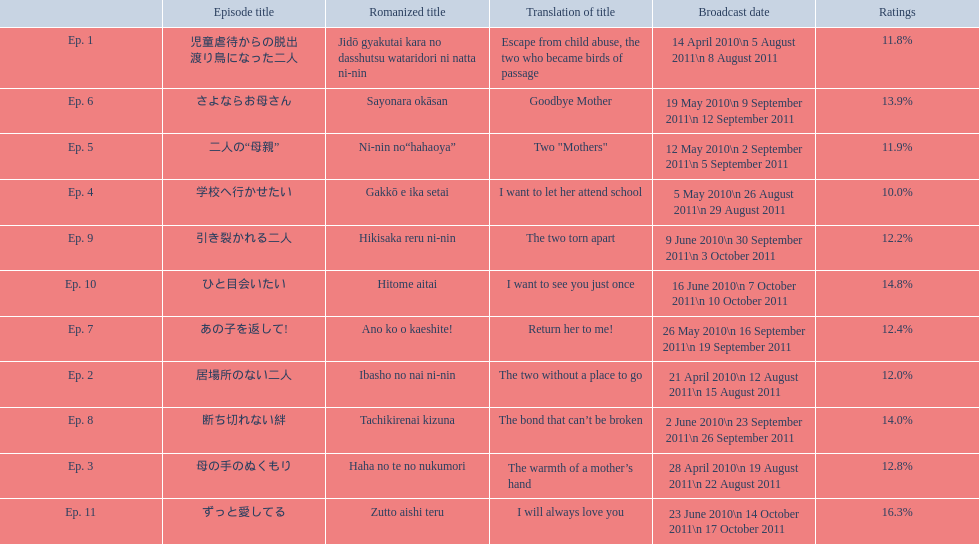What are all the episodes? Ep. 1, Ep. 2, Ep. 3, Ep. 4, Ep. 5, Ep. 6, Ep. 7, Ep. 8, Ep. 9, Ep. 10, Ep. 11. Of these, which ones have a rating of 14%? Ep. 8, Ep. 10. Of these, which one is not ep. 10? Ep. 8. 